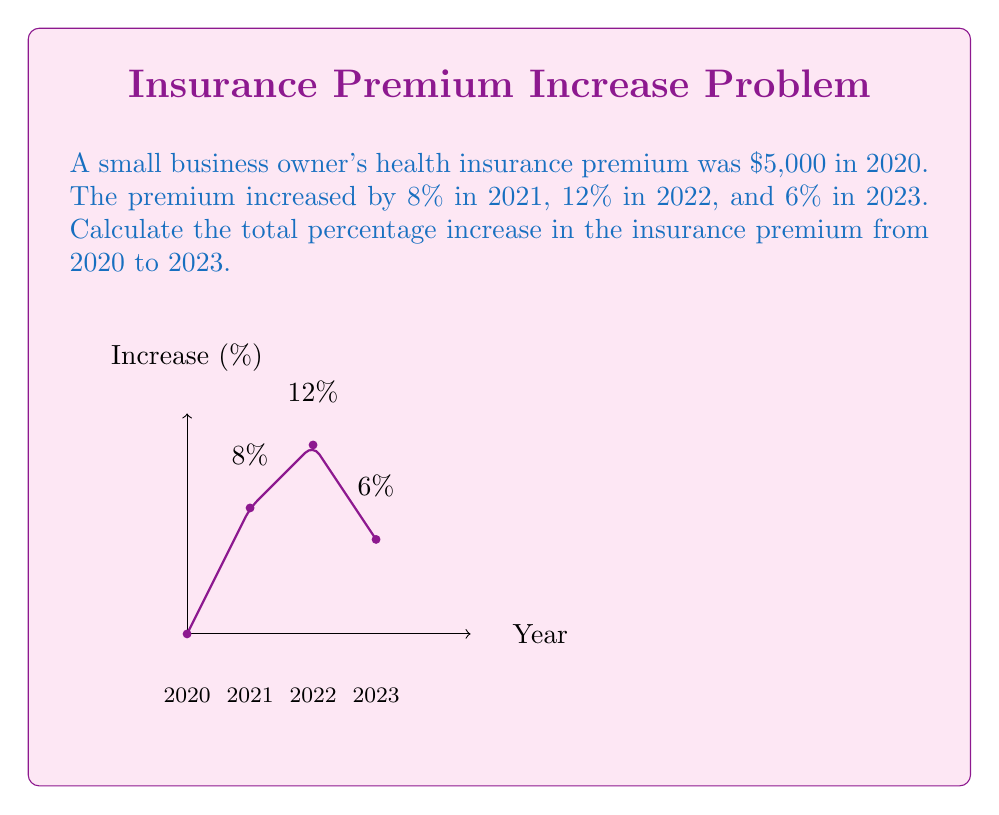Can you answer this question? Let's approach this step-by-step:

1) First, let's calculate the premium for each year:

   2020: $5,000 (given)
   2021: $5,000 * (1 + 0.08) = $5,400
   2022: $5,400 * (1 + 0.12) = $6,048
   2023: $6,048 * (1 + 0.06) = $6,410.88

2) Now, we need to calculate the total percentage increase from 2020 to 2023.
   The formula for percentage increase is:

   $$ \text{Percentage Increase} = \frac{\text{New Value} - \text{Original Value}}{\text{Original Value}} \times 100\% $$

3) Plugging in our values:

   $$ \text{Percentage Increase} = \frac{6410.88 - 5000}{5000} \times 100\% $$

4) Simplifying:

   $$ \text{Percentage Increase} = \frac{1410.88}{5000} \times 100\% = 0.28218 \times 100\% = 28.218\% $$

5) Rounding to two decimal places:

   Total percentage increase = 28.22%

Note: This total increase is not simply the sum of the yearly increases (8% + 12% + 6% = 26%) because each increase compounds on the previous year's premium.
Answer: 28.22% 